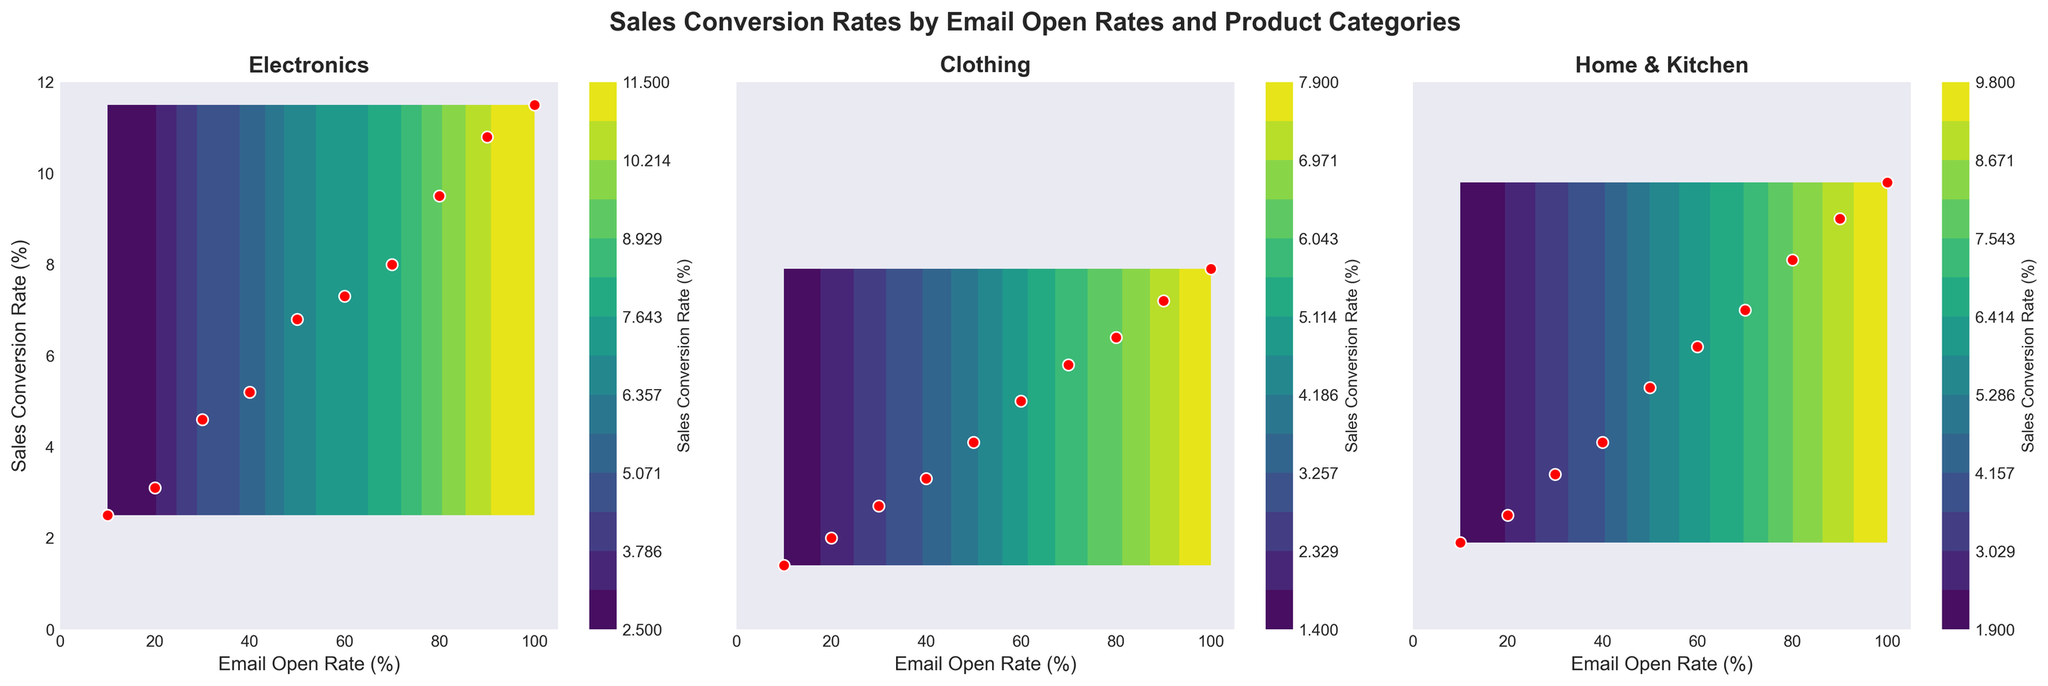What is the title of the figure? The title is displayed at the top of the figure. It reads "Sales Conversion Rates by Email Open Rates and Product Categories".
Answer: Sales Conversion Rates by Email Open Rates and Product Categories Which product category shows the highest Sales Conversion Rate at 100% Email Open Rate? Look at the lines representing 100% Email Open Rate across all subplots and identify the highest value on the y-axis. Electronics reaches the highest at approximately 11.5%.
Answer: Electronics For Electronics, what is the approximate Sales Conversion Rate when the Email Open Rate is 50%? Locate the Electronics subplot and find the 50% mark on the x-axis, then see where it intersects with the contour lines. It’s around 6.8%.
Answer: ~6.8% Which product category has the steepest increase in Sales Conversion Rate as Email Open Rate increases? Compare the slopes of the lines across all subplots. Electronics shows the steepest increase as it has the largest gradient from left (10%) to right (100%).
Answer: Electronics How do the Sales Conversion Rates at 60% Email Open Rate compare between Clothing and Home & Kitchen? Check the 60% Email Open Rate line for both subplots. Clothing is around 5%, while Home & Kitchen is around 6.2%, thus Home & Kitchen is slightly higher.
Answer: Home & Kitchen is higher What is the color scheme used for the contour plots? The figure uses a color gradient that transitions from one color to another, which can be seen in the smooth change of colors from lower to higher Sales Conversion Rates. Specifically, a viridis color map is used showing a transition from purple to yellow.
Answer: viridis What is the range of Sales Conversion Rates displayed in the contour plots on the y-axis? Look at the y-axis across all subplots to determine the range of Sales Conversion Rates represented. The range is from 0% to 12%.
Answer: 0% to 12% At which email open rate does the Sales Conversion Rate for Clothing exceed 3%? Find the Clothing subplot and look for the Email Open Rate corresponding to a 3% Sales Conversion Rate. It’s a bit over 30%.
Answer: ~30% How does the appearance of scatter points correlate with Sales Conversion Rates? Observe that scatter points are in red with a white outline and they indicate specific data points across the contour plots, generally following the contours. Higher densities of scatter points align with higher Sales Conversion Rates.
Answer: They follow the contour lines Which Product Category shows the least variability in Sales Conversion Rates across the range of Email Open Rates? Compare the range of interpolation curves across all subplots. Clothing shows the least pronounced rise, indicating smaller variability.
Answer: Clothing 